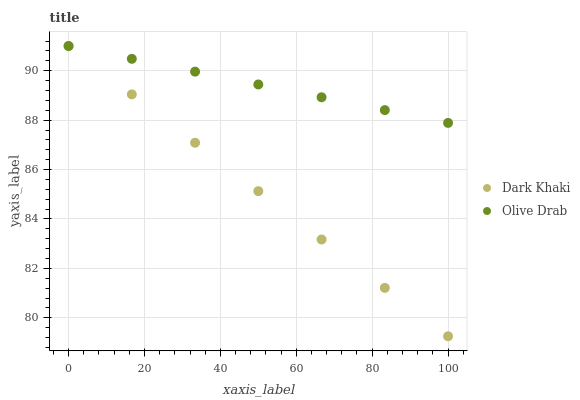Does Dark Khaki have the minimum area under the curve?
Answer yes or no. Yes. Does Olive Drab have the maximum area under the curve?
Answer yes or no. Yes. Does Olive Drab have the minimum area under the curve?
Answer yes or no. No. Is Dark Khaki the smoothest?
Answer yes or no. Yes. Is Olive Drab the roughest?
Answer yes or no. Yes. Is Olive Drab the smoothest?
Answer yes or no. No. Does Dark Khaki have the lowest value?
Answer yes or no. Yes. Does Olive Drab have the lowest value?
Answer yes or no. No. Does Olive Drab have the highest value?
Answer yes or no. Yes. Does Dark Khaki intersect Olive Drab?
Answer yes or no. Yes. Is Dark Khaki less than Olive Drab?
Answer yes or no. No. Is Dark Khaki greater than Olive Drab?
Answer yes or no. No. 